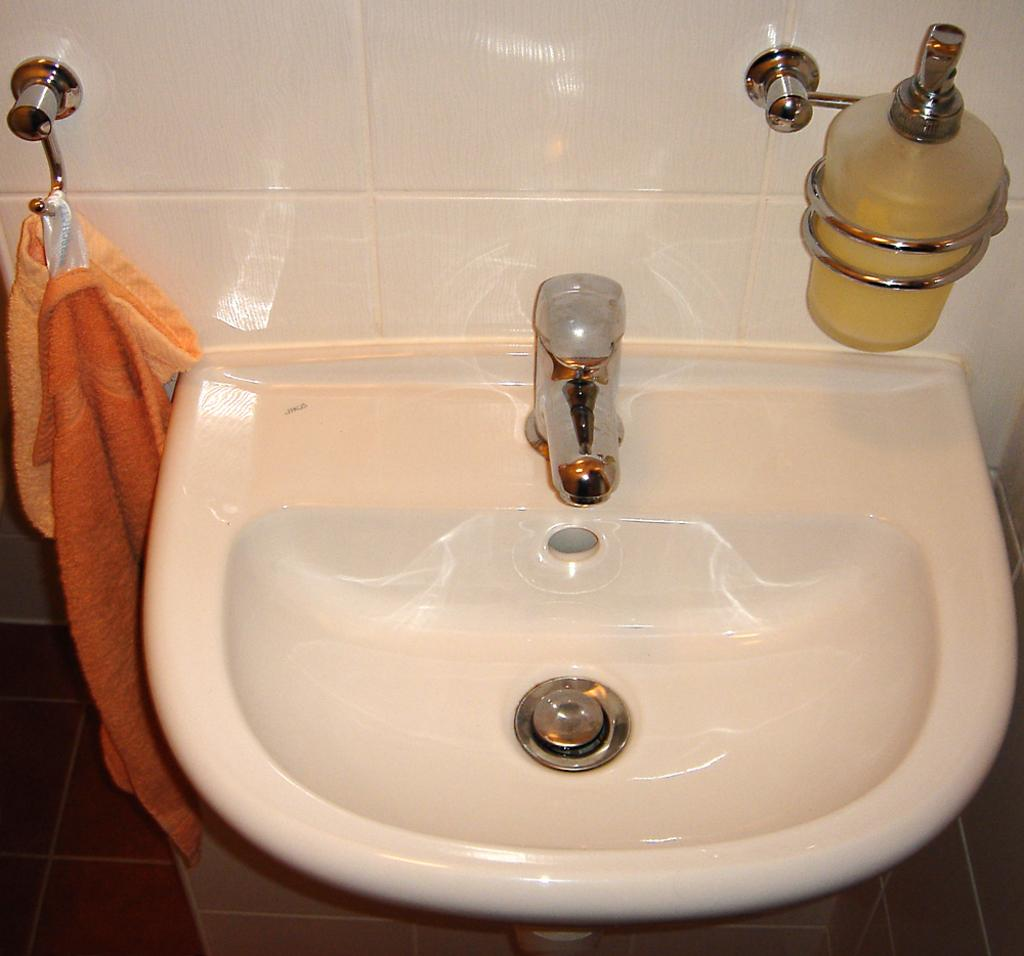What can be seen in the image that dispenses water? There is a sink with a tap in the image. What is used for cleaning hands in the image? There is a hand wash bottle in the image. What is used for drying hands in the image? There is a napkin with a hanger in the image. What is the color and material of the wall in the image? The wall has white tiles in the image. What is the color and material of the floor in the image? The floor has red tiles in the image. What type of butter can be seen on the wall in the image? There is no butter present on the wall in the image. How does the acoustics of the room affect the sound in the image? The image does not provide information about the acoustics of the room, so it cannot be determined how it affects the sound. 